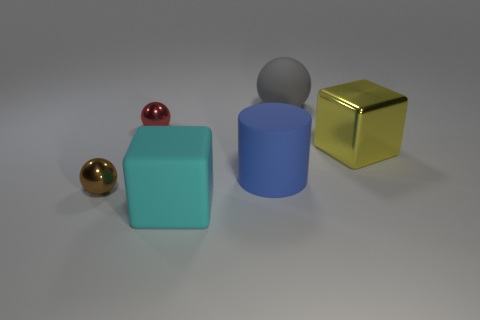Add 4 small brown objects. How many objects exist? 10 Subtract all tiny metallic spheres. How many spheres are left? 1 Subtract all yellow cubes. How many cubes are left? 1 Subtract all cylinders. How many objects are left? 5 Subtract all blue cylinders. Subtract all red balls. How many objects are left? 4 Add 5 gray matte objects. How many gray matte objects are left? 6 Add 3 small objects. How many small objects exist? 5 Subtract 0 blue cubes. How many objects are left? 6 Subtract all gray cubes. Subtract all gray cylinders. How many cubes are left? 2 